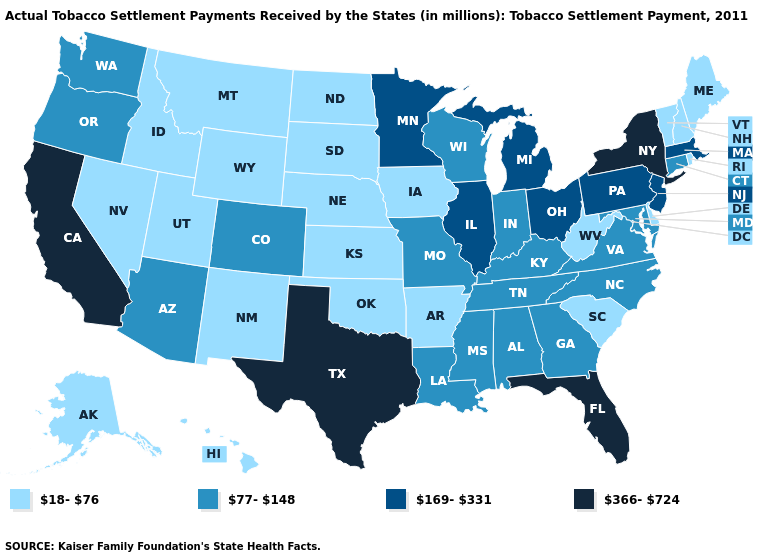What is the lowest value in states that border Oklahoma?
Keep it brief. 18-76. Which states have the lowest value in the USA?
Give a very brief answer. Alaska, Arkansas, Delaware, Hawaii, Idaho, Iowa, Kansas, Maine, Montana, Nebraska, Nevada, New Hampshire, New Mexico, North Dakota, Oklahoma, Rhode Island, South Carolina, South Dakota, Utah, Vermont, West Virginia, Wyoming. What is the highest value in states that border Massachusetts?
Quick response, please. 366-724. Does Iowa have the lowest value in the MidWest?
Keep it brief. Yes. Among the states that border Colorado , does Arizona have the highest value?
Answer briefly. Yes. What is the value of Oklahoma?
Answer briefly. 18-76. What is the value of West Virginia?
Give a very brief answer. 18-76. Is the legend a continuous bar?
Write a very short answer. No. What is the highest value in states that border New York?
Keep it brief. 169-331. What is the lowest value in the USA?
Concise answer only. 18-76. Which states hav the highest value in the South?
Be succinct. Florida, Texas. Does Alabama have the highest value in the USA?
Quick response, please. No. Name the states that have a value in the range 77-148?
Concise answer only. Alabama, Arizona, Colorado, Connecticut, Georgia, Indiana, Kentucky, Louisiana, Maryland, Mississippi, Missouri, North Carolina, Oregon, Tennessee, Virginia, Washington, Wisconsin. Among the states that border New Mexico , does Utah have the lowest value?
Answer briefly. Yes. Among the states that border Maine , which have the highest value?
Quick response, please. New Hampshire. 